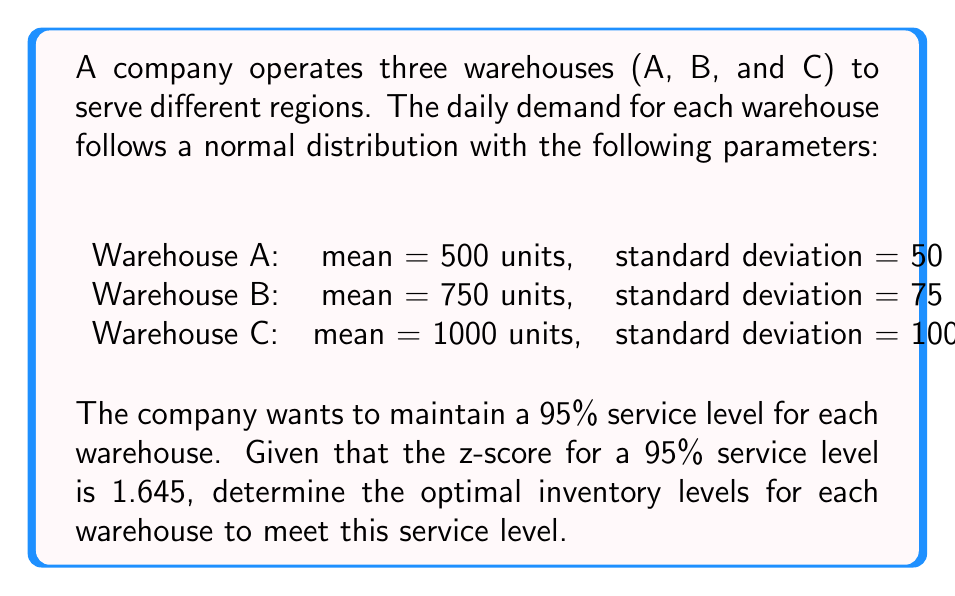Provide a solution to this math problem. To determine the optimal inventory levels for each warehouse, we'll use the formula:

$$\text{Optimal Inventory Level} = \mu + z\sigma$$

Where:
$\mu$ is the mean demand
$z$ is the z-score for the desired service level
$\sigma$ is the standard deviation of demand

Given:
- Service level: 95%
- z-score for 95% service level: 1.645

For Warehouse A:
$\mu_A = 500$, $\sigma_A = 50$
$$\text{Optimal Inventory Level}_A = 500 + (1.645 \times 50) = 500 + 82.25 = 582.25$$

For Warehouse B:
$\mu_B = 750$, $\sigma_B = 75$
$$\text{Optimal Inventory Level}_B = 750 + (1.645 \times 75) = 750 + 123.375 = 873.375$$

For Warehouse C:
$\mu_C = 1000$, $\sigma_C = 100$
$$\text{Optimal Inventory Level}_C = 1000 + (1.645 \times 100) = 1000 + 164.5 = 1164.5$$

Rounding up to the nearest whole unit for practical inventory management:
Warehouse A: 583 units
Warehouse B: 874 units
Warehouse C: 1165 units
Answer: Warehouse A: 583 units, Warehouse B: 874 units, Warehouse C: 1165 units 